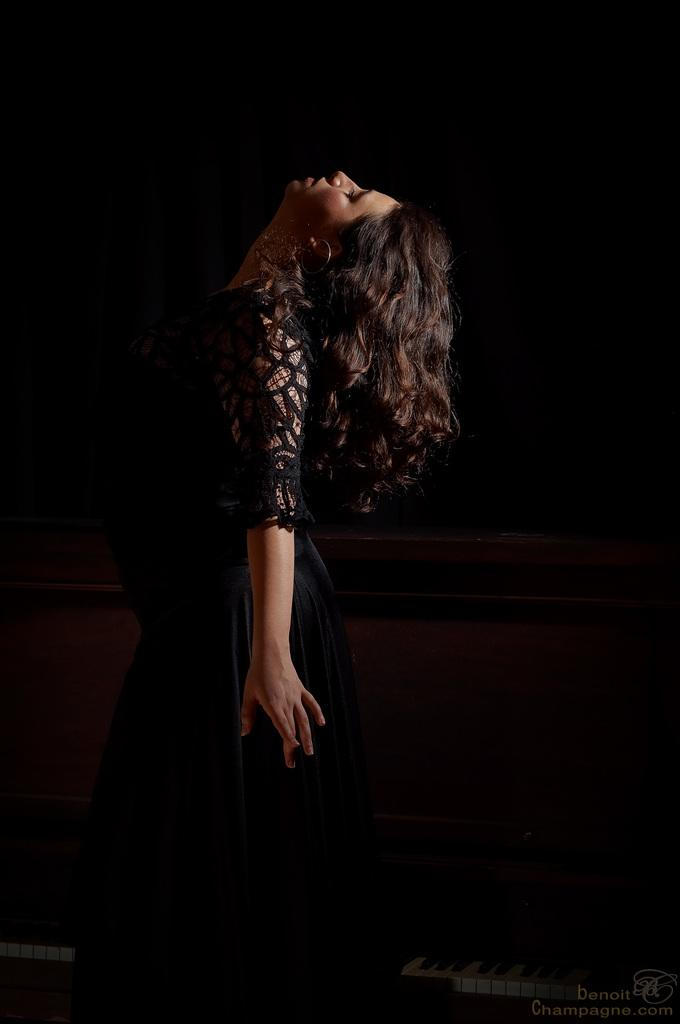Who is the main subject in the image? There is a lady in the image. What is the lady wearing? The lady is wearing a black dress. What is the lady doing in the image? The lady is standing. What can be observed about the background of the image? The background of the image is dark. What type of horn can be heard in the image? There is no horn or sound present in the image; it is a still image of a lady wearing a black dress and standing. 